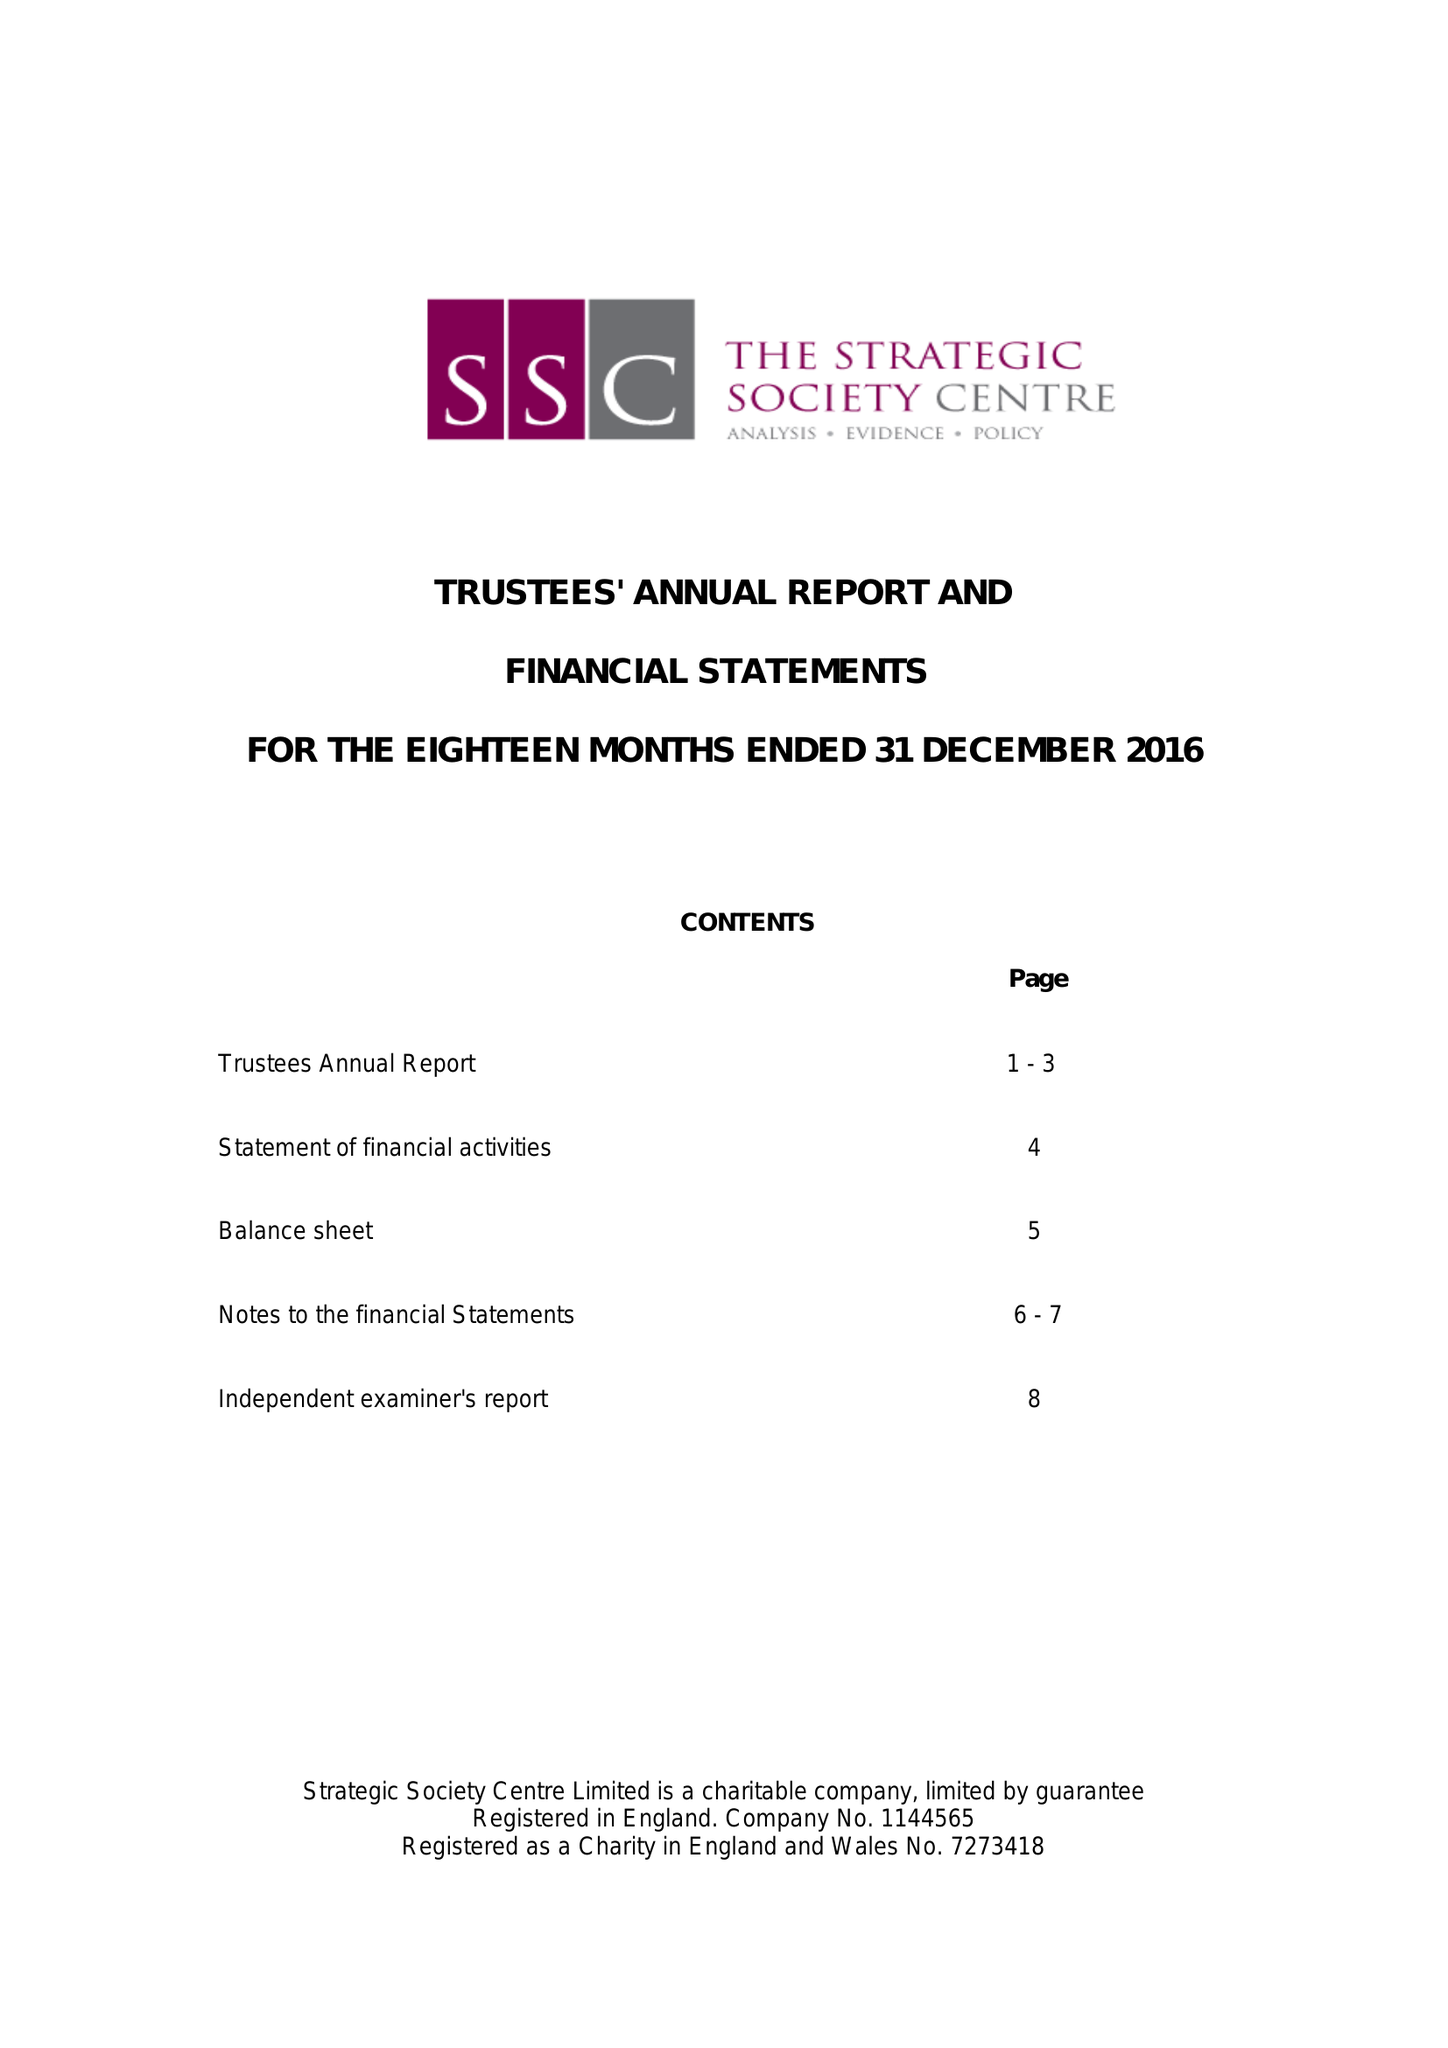What is the value for the address__postcode?
Answer the question using a single word or phrase. N1 7GU 